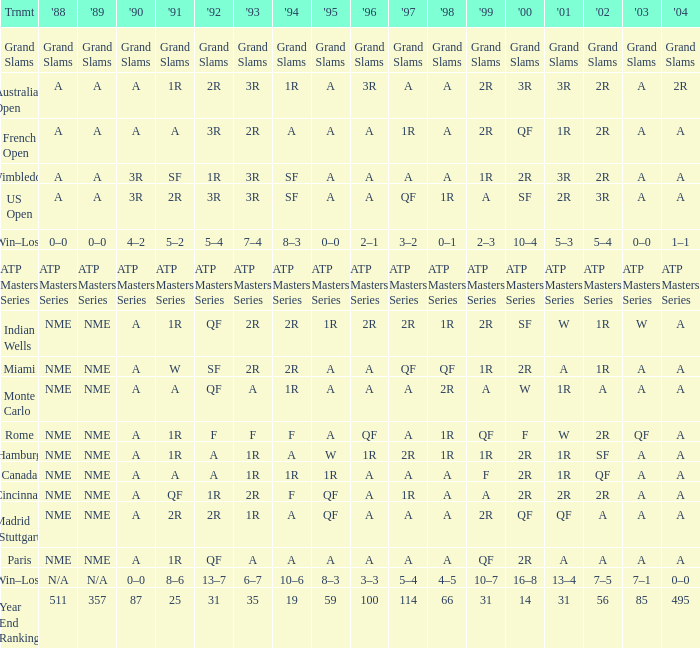What shows for 202 when the 1994 is A, the 1989 is NME, and the 199 is 2R? A. 